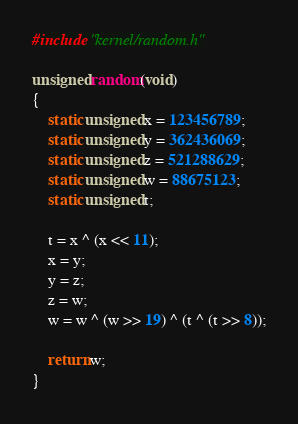Convert code to text. <code><loc_0><loc_0><loc_500><loc_500><_C_>#include "kernel/random.h"

unsigned random(void)
{
	static unsigned x = 123456789;
	static unsigned y = 362436069;
	static unsigned z = 521288629;
	static unsigned w = 88675123;
	static unsigned t;

	t = x ^ (x << 11);
	x = y;
	y = z;
	z = w;
	w = w ^ (w >> 19) ^ (t ^ (t >> 8));

	return w;
}
</code> 